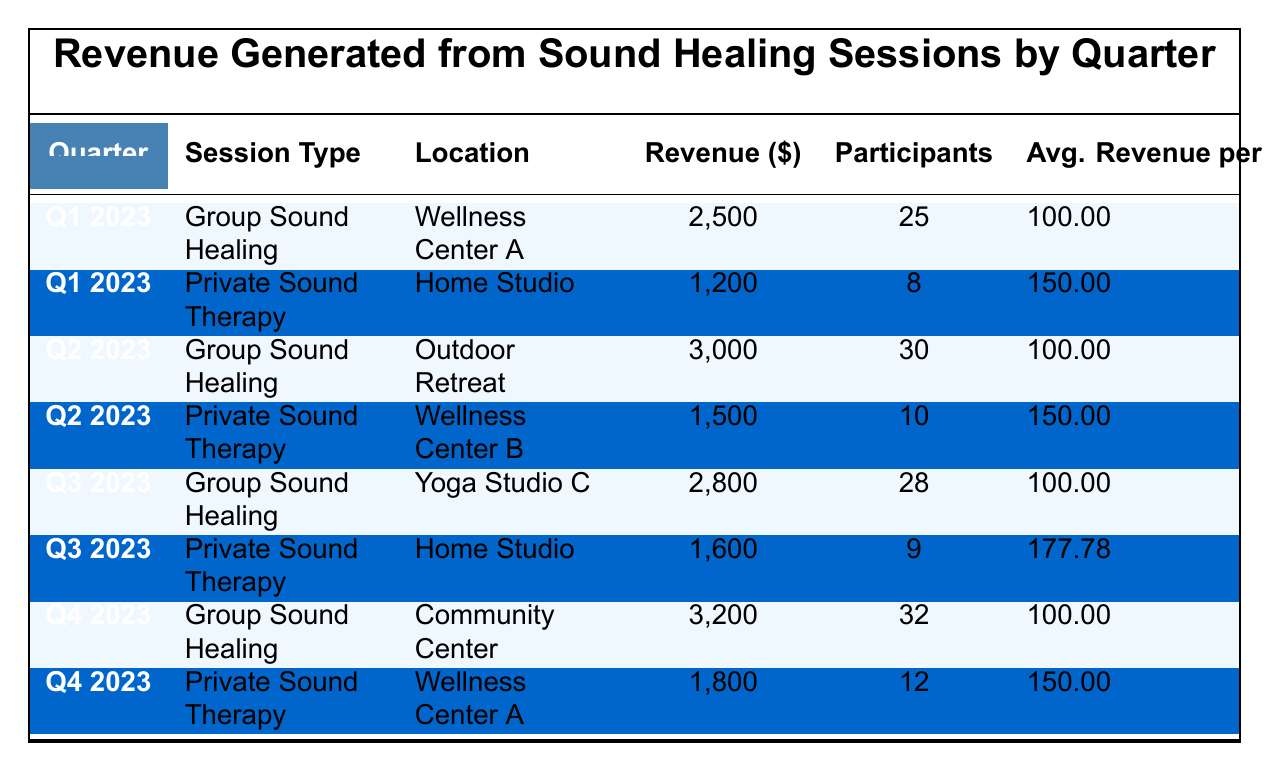What was the total revenue generated from Group Sound Healing sessions in Q2 2023? In Q2 2023, the revenue from Group Sound Healing is reported as 3000. Therefore, the total revenue for this session type in this quarter is simply 3000.
Answer: 3000 How many participants attended Private Sound Therapy sessions across all quarters? Adding the participants from each quarter gives us: 8 (Q1) + 10 (Q2) + 9 (Q3) + 12 (Q4) = 39. Therefore, the total number of participants for Private Sound Therapy sessions is 39.
Answer: 39 What is the average revenue per participant for Private Sound Therapy sessions in Q3 2023? In Q3 2023, Private Sound Therapy generated 1600 revenue from 9 participants. The average is calculated as 1600 / 9 ≈ 177.78.
Answer: 177.78 Was the average revenue per participant for Group Sound Healing sessions the same across all quarters? The average revenue per participant for Group Sound Healing in each quarter is consistently 100.00. Since this value does not change, the statement is true.
Answer: Yes What was the total revenue generated across all sessions by the end of Q4 2023? By summing the revenue from all sessions, we have: 2500 (Q1) + 1200 (Q1) + 3000 (Q2) + 1500 (Q2) + 2800 (Q3) + 1600 (Q3) + 3200 (Q4) + 1800 (Q4) = 18600. Therefore, the total revenue is 18600.
Answer: 18600 Which session type had the highest revenue in Q4 2023, and what was that amount? In Q4 2023, Group Sound Healing earned 3200, while Private Sound Therapy earned 1800. Thus, the highest revenue is from Group Sound Healing at 3200.
Answer: Group Sound Healing, 3200 How did the revenue from Group Sound Healing in Q2 2023 compare with Q3 2023? In Q2 2023, Group Sound Healing earned 3000, while in Q3 2023 it earned 2800. The revenue decreased by 200 from Q2 to Q3.
Answer: Decreased by 200 Is it true that the revenue from each type of session was the same across the quarters? Examining the revenue amounts, it's clear that the revenues differ between quarters for both Group Sound Healing and Private Sound Therapy, indicating the statement is false.
Answer: No 